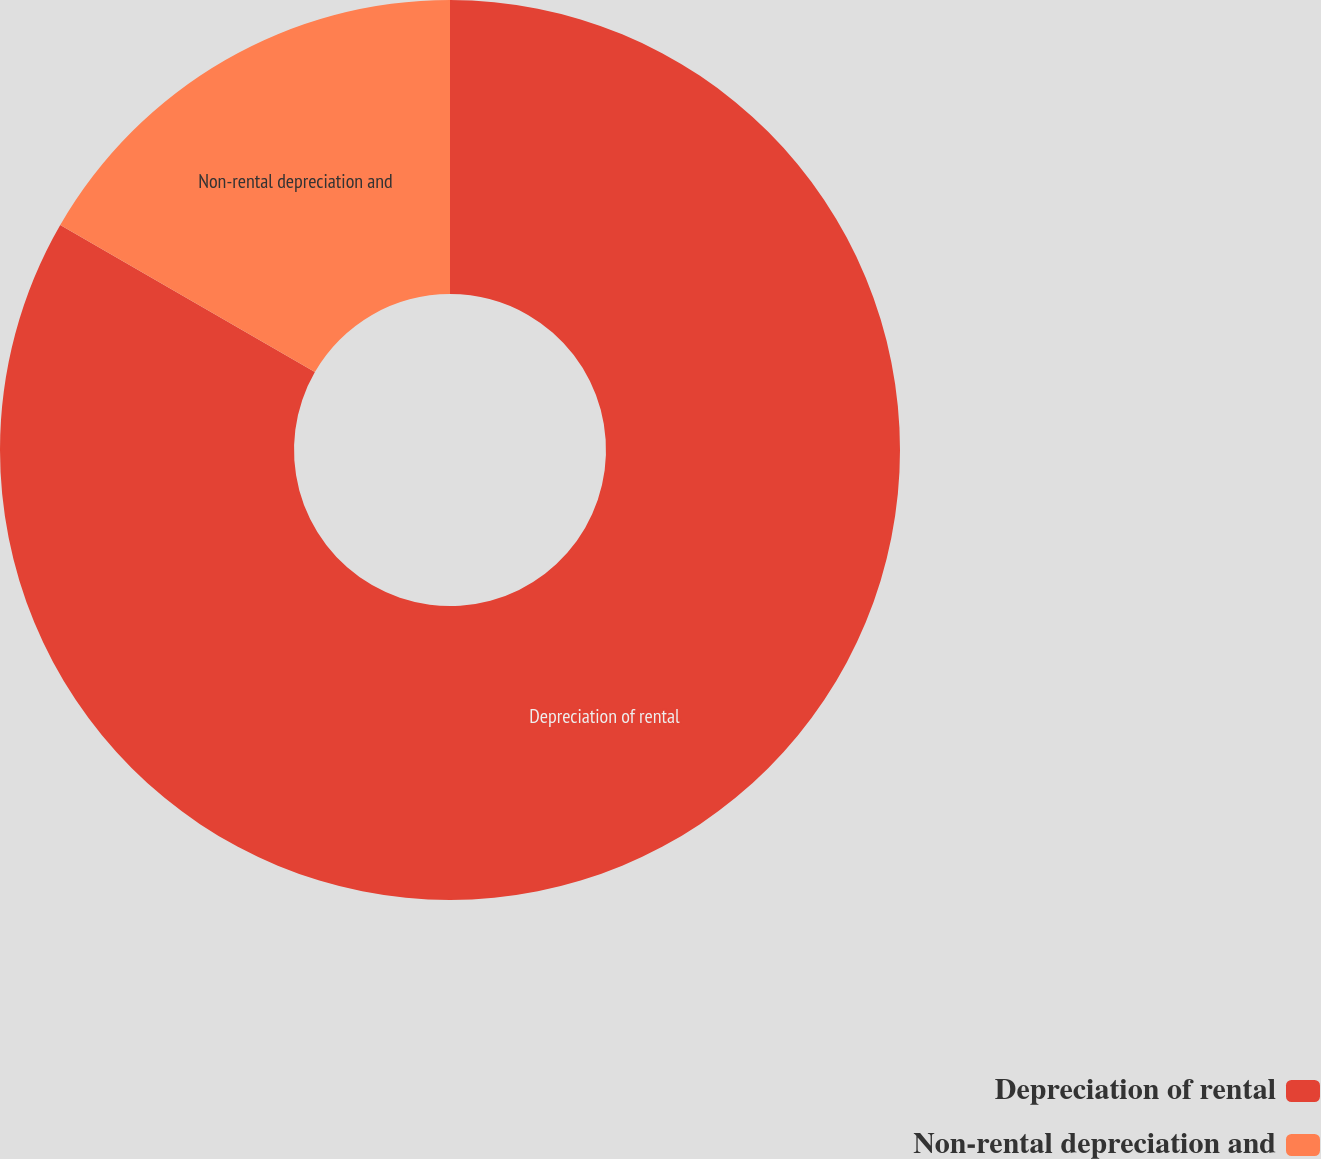Convert chart. <chart><loc_0><loc_0><loc_500><loc_500><pie_chart><fcel>Depreciation of rental<fcel>Non-rental depreciation and<nl><fcel>83.33%<fcel>16.67%<nl></chart> 